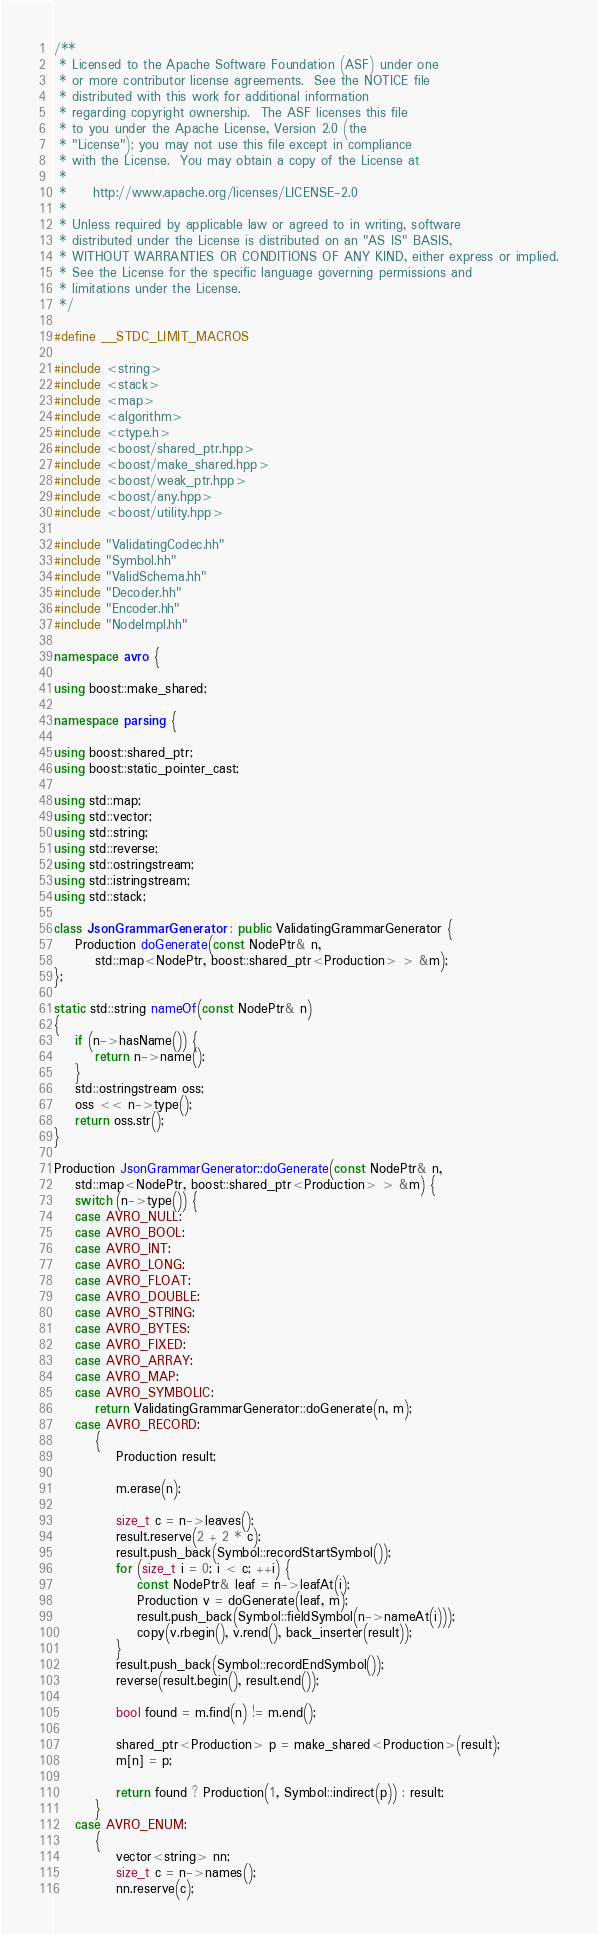Convert code to text. <code><loc_0><loc_0><loc_500><loc_500><_C++_>/**
 * Licensed to the Apache Software Foundation (ASF) under one
 * or more contributor license agreements.  See the NOTICE file
 * distributed with this work for additional information
 * regarding copyright ownership.  The ASF licenses this file
 * to you under the Apache License, Version 2.0 (the
 * "License"); you may not use this file except in compliance
 * with the License.  You may obtain a copy of the License at
 *
 *     http://www.apache.org/licenses/LICENSE-2.0
 *
 * Unless required by applicable law or agreed to in writing, software
 * distributed under the License is distributed on an "AS IS" BASIS,
 * WITHOUT WARRANTIES OR CONDITIONS OF ANY KIND, either express or implied.
 * See the License for the specific language governing permissions and
 * limitations under the License.
 */

#define __STDC_LIMIT_MACROS

#include <string>
#include <stack>
#include <map>
#include <algorithm>
#include <ctype.h>
#include <boost/shared_ptr.hpp>
#include <boost/make_shared.hpp>
#include <boost/weak_ptr.hpp>
#include <boost/any.hpp>
#include <boost/utility.hpp>

#include "ValidatingCodec.hh"
#include "Symbol.hh"
#include "ValidSchema.hh"
#include "Decoder.hh"
#include "Encoder.hh"
#include "NodeImpl.hh"

namespace avro {

using boost::make_shared;

namespace parsing {

using boost::shared_ptr;
using boost::static_pointer_cast;

using std::map;
using std::vector;
using std::string;
using std::reverse;
using std::ostringstream;
using std::istringstream;
using std::stack;

class JsonGrammarGenerator : public ValidatingGrammarGenerator {
    Production doGenerate(const NodePtr& n,
        std::map<NodePtr, boost::shared_ptr<Production> > &m);
};

static std::string nameOf(const NodePtr& n)
{
    if (n->hasName()) {
        return n->name();
    }
    std::ostringstream oss;
    oss << n->type();
    return oss.str();
}

Production JsonGrammarGenerator::doGenerate(const NodePtr& n,
    std::map<NodePtr, boost::shared_ptr<Production> > &m) {
    switch (n->type()) {
    case AVRO_NULL:
    case AVRO_BOOL:
    case AVRO_INT:
    case AVRO_LONG:
    case AVRO_FLOAT:
    case AVRO_DOUBLE:
    case AVRO_STRING:
    case AVRO_BYTES:
    case AVRO_FIXED:
    case AVRO_ARRAY:
    case AVRO_MAP:
    case AVRO_SYMBOLIC:
        return ValidatingGrammarGenerator::doGenerate(n, m);
    case AVRO_RECORD:
        {
            Production result;

            m.erase(n);

            size_t c = n->leaves();
            result.reserve(2 + 2 * c);
            result.push_back(Symbol::recordStartSymbol());
            for (size_t i = 0; i < c; ++i) {
                const NodePtr& leaf = n->leafAt(i);
                Production v = doGenerate(leaf, m);
                result.push_back(Symbol::fieldSymbol(n->nameAt(i)));
                copy(v.rbegin(), v.rend(), back_inserter(result));
            }
            result.push_back(Symbol::recordEndSymbol());
            reverse(result.begin(), result.end());

            bool found = m.find(n) != m.end();

            shared_ptr<Production> p = make_shared<Production>(result);
            m[n] = p;

            return found ? Production(1, Symbol::indirect(p)) : result;
        }
    case AVRO_ENUM:
        {
            vector<string> nn;
            size_t c = n->names();
            nn.reserve(c);</code> 